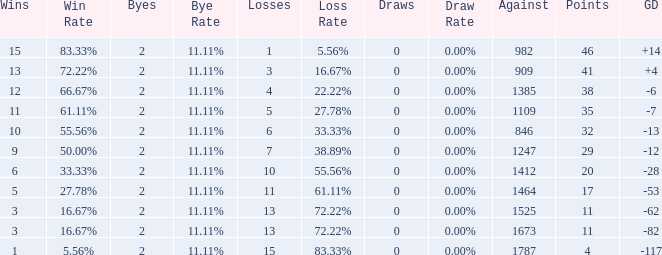What is the highest number listed under against when there were less than 3 wins and less than 15 losses? None. 